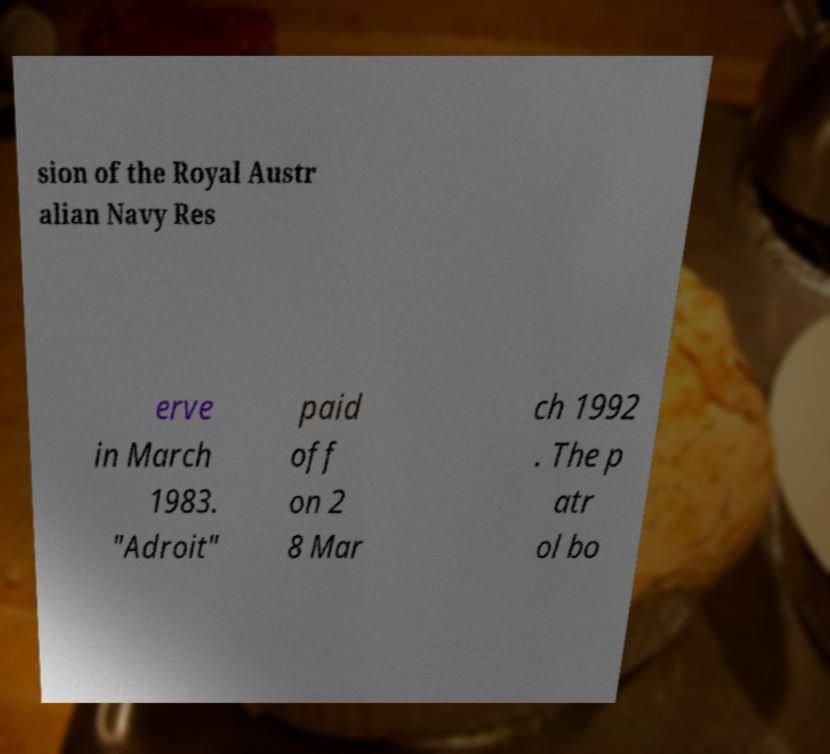Please read and relay the text visible in this image. What does it say? sion of the Royal Austr alian Navy Res erve in March 1983. "Adroit" paid off on 2 8 Mar ch 1992 . The p atr ol bo 